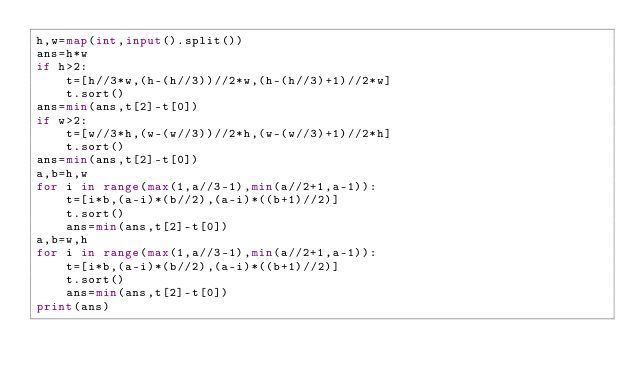Convert code to text. <code><loc_0><loc_0><loc_500><loc_500><_Python_>h,w=map(int,input().split())
ans=h*w
if h>2:
    t=[h//3*w,(h-(h//3))//2*w,(h-(h//3)+1)//2*w]
    t.sort()
ans=min(ans,t[2]-t[0])
if w>2:
    t=[w//3*h,(w-(w//3))//2*h,(w-(w//3)+1)//2*h]
    t.sort()
ans=min(ans,t[2]-t[0])
a,b=h,w
for i in range(max(1,a//3-1),min(a//2+1,a-1)):
    t=[i*b,(a-i)*(b//2),(a-i)*((b+1)//2)]
    t.sort()
    ans=min(ans,t[2]-t[0])
a,b=w,h
for i in range(max(1,a//3-1),min(a//2+1,a-1)):
    t=[i*b,(a-i)*(b//2),(a-i)*((b+1)//2)]
    t.sort()
    ans=min(ans,t[2]-t[0])
print(ans)</code> 